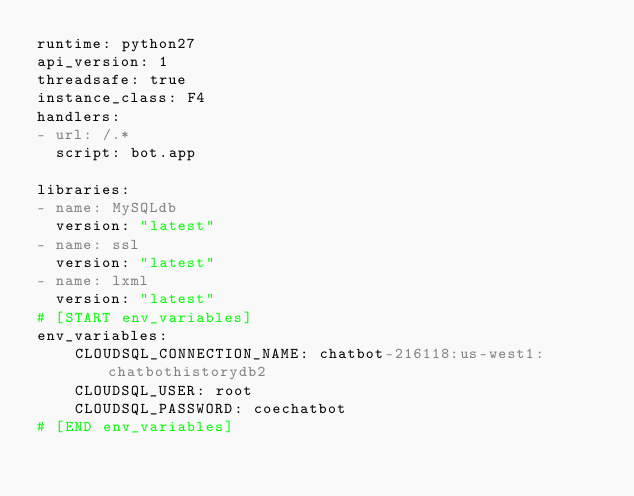<code> <loc_0><loc_0><loc_500><loc_500><_YAML_>runtime: python27
api_version: 1
threadsafe: true
instance_class: F4
handlers:
- url: /.*
  script: bot.app

libraries:
- name: MySQLdb
  version: "latest"
- name: ssl
  version: "latest"
- name: lxml
  version: "latest" 
# [START env_variables]
env_variables:
    CLOUDSQL_CONNECTION_NAME: chatbot-216118:us-west1:chatbothistorydb2
    CLOUDSQL_USER: root
    CLOUDSQL_PASSWORD: coechatbot
# [END env_variables]
</code> 